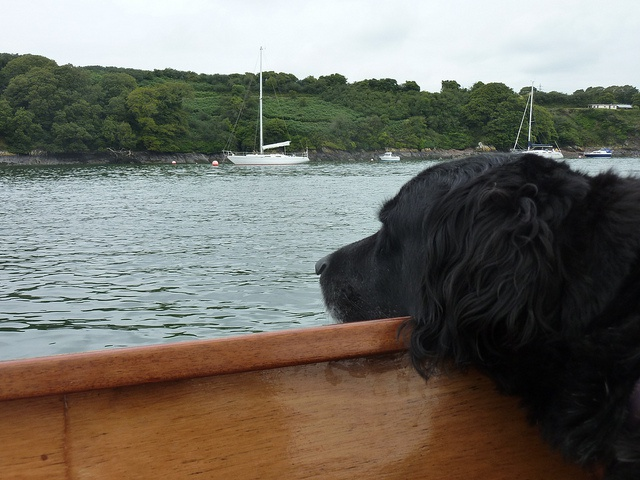Describe the objects in this image and their specific colors. I can see dog in white, black, and gray tones, boat in white, brown, maroon, and gray tones, boat in white, lightgray, darkgray, and gray tones, boat in white, lightgray, darkgray, gray, and black tones, and boat in white, gray, darkgray, and navy tones in this image. 